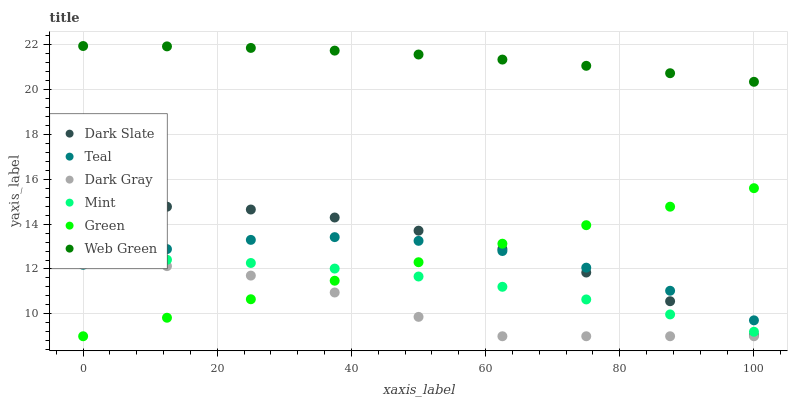Does Dark Gray have the minimum area under the curve?
Answer yes or no. Yes. Does Web Green have the maximum area under the curve?
Answer yes or no. Yes. Does Dark Slate have the minimum area under the curve?
Answer yes or no. No. Does Dark Slate have the maximum area under the curve?
Answer yes or no. No. Is Green the smoothest?
Answer yes or no. Yes. Is Dark Gray the roughest?
Answer yes or no. Yes. Is Dark Slate the smoothest?
Answer yes or no. No. Is Dark Slate the roughest?
Answer yes or no. No. Does Dark Gray have the lowest value?
Answer yes or no. Yes. Does Dark Slate have the lowest value?
Answer yes or no. No. Does Web Green have the highest value?
Answer yes or no. Yes. Does Dark Slate have the highest value?
Answer yes or no. No. Is Dark Slate less than Web Green?
Answer yes or no. Yes. Is Web Green greater than Green?
Answer yes or no. Yes. Does Dark Slate intersect Green?
Answer yes or no. Yes. Is Dark Slate less than Green?
Answer yes or no. No. Is Dark Slate greater than Green?
Answer yes or no. No. Does Dark Slate intersect Web Green?
Answer yes or no. No. 